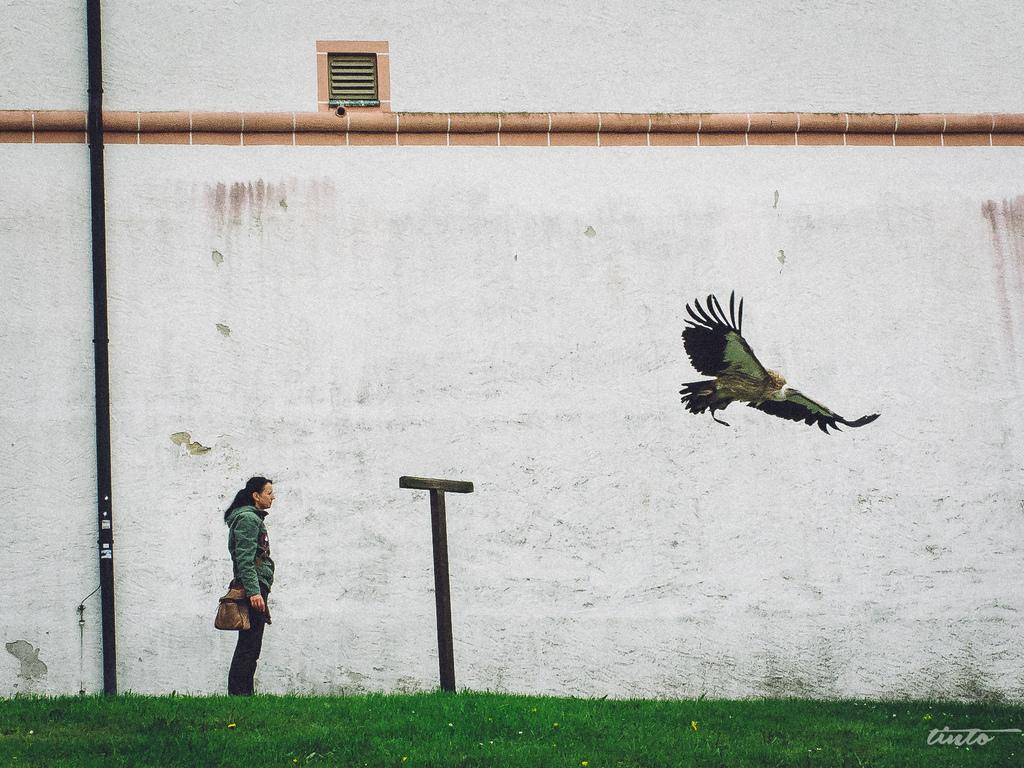Please provide a concise description of this image. In this image we can see a person is standing on the left side and carrying a bag on the shoulder and on the right side there is a bird flying in the air and in between them there is an object. At the bottom we can see grass on the ground. In the background we can see pipe on the wall and window. 